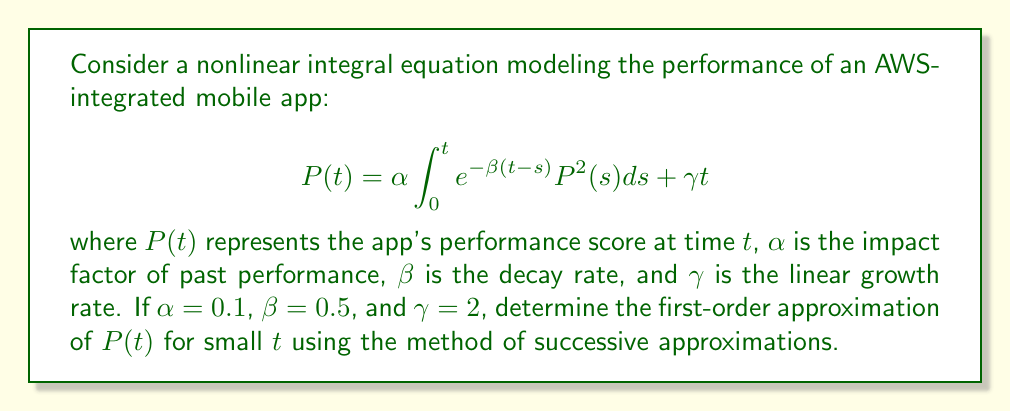Can you answer this question? To solve this nonlinear integral equation, we'll use the method of successive approximations:

1) Start with the initial approximation $P_0(t) = \gamma t$:
   $$P_0(t) = 2t$$

2) Substitute this into the right-hand side of the equation to get $P_1(t)$:
   $$P_1(t) = 0.1 \int_0^t e^{-0.5(t-s)} (2s)^2 ds + 2t$$

3) Evaluate the integral:
   $$\begin{align}
   P_1(t) &= 0.4 \int_0^t e^{-0.5(t-s)} s^2 ds + 2t \\
   &= 0.4 \left[ -2e^{-0.5t} \int_0^t e^{0.5s} s^2 ds \right] + 2t
   \end{align}$$

4) Integrate by parts twice:
   $$\begin{align}
   P_1(t) &= 0.4 \left[ -2e^{-0.5t} \left( \frac{4}{0.5^3}e^{0.5t} - \frac{4}{0.5^2}te^{0.5t} + \frac{2}{0.5}t^2e^{0.5t} \right) \right] + 2t \\
   &= 0.4 \left( -\frac{32}{0.5^3} + \frac{32}{0.5^2}t - \frac{16}{0.5}t^2 + \frac{8}{0.5^3}e^{-0.5t} \right) + 2t
   \end{align}$$

5) Simplify:
   $$P_1(t) = -51.2 + 51.2t - 12.8t^2 + 25.6e^{-0.5t} + 2t$$

6) For small $t$, we can use the Taylor expansion of $e^{-0.5t}$ up to the second order:
   $$e^{-0.5t} \approx 1 - 0.5t + \frac{0.5^2}{2}t^2 = 1 - 0.5t + 0.125t^2$$

7) Substitute this approximation:
   $$\begin{align}
   P_1(t) &\approx -51.2 + 51.2t - 12.8t^2 + 25.6(1 - 0.5t + 0.125t^2) + 2t \\
   &= (-51.2 + 25.6) + (51.2 - 12.8 + 2)t + (-12.8 + 3.2)t^2 \\
   &= -25.6 + 40.4t - 9.6t^2
   \end{align}$$

8) This is our first-order approximation of $P(t)$ for small $t$.
Answer: $P(t) \approx -25.6 + 40.4t - 9.6t^2$ 